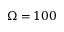Convert formula to latex. <formula><loc_0><loc_0><loc_500><loc_500>\Omega = 1 0 0</formula> 